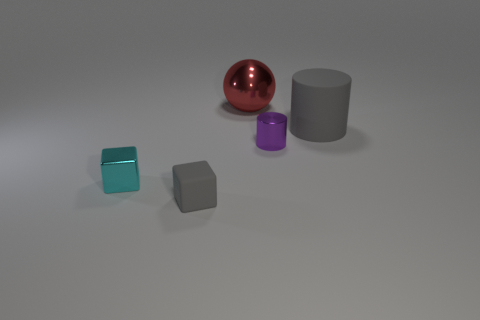Add 5 large red spheres. How many objects exist? 10 Subtract all cylinders. How many objects are left? 3 Add 1 yellow blocks. How many yellow blocks exist? 1 Subtract 1 gray cylinders. How many objects are left? 4 Subtract all large objects. Subtract all small brown rubber blocks. How many objects are left? 3 Add 2 big red objects. How many big red objects are left? 3 